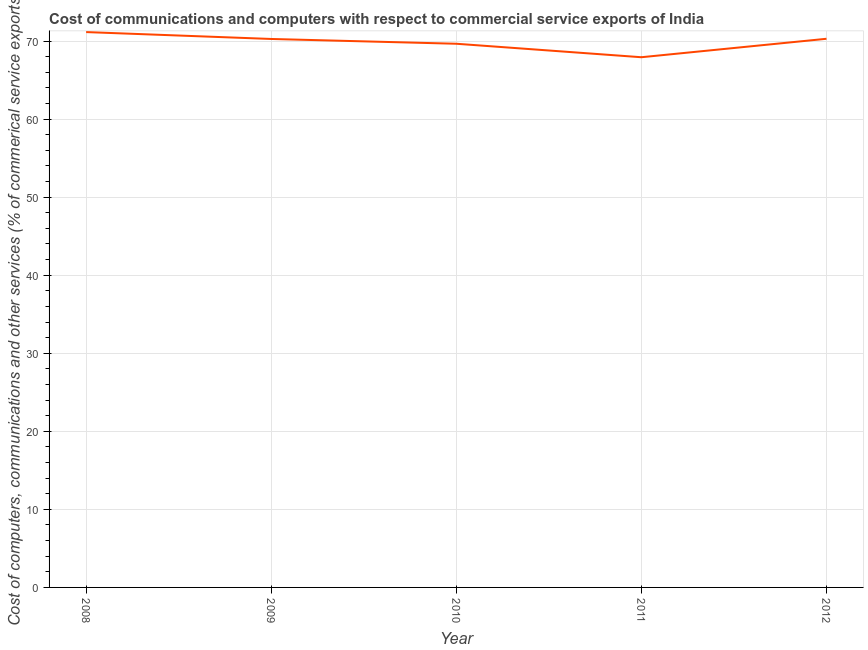What is the cost of communications in 2012?
Your response must be concise. 70.29. Across all years, what is the maximum  computer and other services?
Give a very brief answer. 71.15. Across all years, what is the minimum  computer and other services?
Provide a short and direct response. 67.93. What is the sum of the cost of communications?
Offer a very short reply. 349.28. What is the difference between the cost of communications in 2008 and 2009?
Provide a short and direct response. 0.88. What is the average cost of communications per year?
Make the answer very short. 69.86. What is the median cost of communications?
Your answer should be very brief. 70.27. In how many years, is the cost of communications greater than 52 %?
Your response must be concise. 5. What is the ratio of the cost of communications in 2009 to that in 2010?
Make the answer very short. 1.01. Is the cost of communications in 2008 less than that in 2010?
Make the answer very short. No. What is the difference between the highest and the second highest  computer and other services?
Offer a terse response. 0.86. What is the difference between the highest and the lowest  computer and other services?
Provide a succinct answer. 3.22. In how many years, is the  computer and other services greater than the average  computer and other services taken over all years?
Provide a succinct answer. 3. Does the  computer and other services monotonically increase over the years?
Provide a succinct answer. No. How many lines are there?
Give a very brief answer. 1. How many years are there in the graph?
Your answer should be compact. 5. What is the difference between two consecutive major ticks on the Y-axis?
Provide a succinct answer. 10. Are the values on the major ticks of Y-axis written in scientific E-notation?
Offer a terse response. No. Does the graph contain grids?
Provide a succinct answer. Yes. What is the title of the graph?
Keep it short and to the point. Cost of communications and computers with respect to commercial service exports of India. What is the label or title of the X-axis?
Provide a short and direct response. Year. What is the label or title of the Y-axis?
Keep it short and to the point. Cost of computers, communications and other services (% of commerical service exports). What is the Cost of computers, communications and other services (% of commerical service exports) of 2008?
Offer a very short reply. 71.15. What is the Cost of computers, communications and other services (% of commerical service exports) of 2009?
Keep it short and to the point. 70.27. What is the Cost of computers, communications and other services (% of commerical service exports) in 2010?
Your answer should be very brief. 69.65. What is the Cost of computers, communications and other services (% of commerical service exports) of 2011?
Offer a very short reply. 67.93. What is the Cost of computers, communications and other services (% of commerical service exports) in 2012?
Ensure brevity in your answer.  70.29. What is the difference between the Cost of computers, communications and other services (% of commerical service exports) in 2008 and 2009?
Keep it short and to the point. 0.88. What is the difference between the Cost of computers, communications and other services (% of commerical service exports) in 2008 and 2010?
Make the answer very short. 1.49. What is the difference between the Cost of computers, communications and other services (% of commerical service exports) in 2008 and 2011?
Your response must be concise. 3.22. What is the difference between the Cost of computers, communications and other services (% of commerical service exports) in 2008 and 2012?
Your answer should be compact. 0.86. What is the difference between the Cost of computers, communications and other services (% of commerical service exports) in 2009 and 2010?
Provide a succinct answer. 0.61. What is the difference between the Cost of computers, communications and other services (% of commerical service exports) in 2009 and 2011?
Ensure brevity in your answer.  2.34. What is the difference between the Cost of computers, communications and other services (% of commerical service exports) in 2009 and 2012?
Ensure brevity in your answer.  -0.03. What is the difference between the Cost of computers, communications and other services (% of commerical service exports) in 2010 and 2011?
Offer a terse response. 1.73. What is the difference between the Cost of computers, communications and other services (% of commerical service exports) in 2010 and 2012?
Offer a terse response. -0.64. What is the difference between the Cost of computers, communications and other services (% of commerical service exports) in 2011 and 2012?
Your answer should be very brief. -2.36. What is the ratio of the Cost of computers, communications and other services (% of commerical service exports) in 2008 to that in 2009?
Ensure brevity in your answer.  1.01. What is the ratio of the Cost of computers, communications and other services (% of commerical service exports) in 2008 to that in 2010?
Provide a succinct answer. 1.02. What is the ratio of the Cost of computers, communications and other services (% of commerical service exports) in 2008 to that in 2011?
Keep it short and to the point. 1.05. What is the ratio of the Cost of computers, communications and other services (% of commerical service exports) in 2008 to that in 2012?
Provide a short and direct response. 1.01. What is the ratio of the Cost of computers, communications and other services (% of commerical service exports) in 2009 to that in 2011?
Offer a terse response. 1.03. What is the ratio of the Cost of computers, communications and other services (% of commerical service exports) in 2011 to that in 2012?
Make the answer very short. 0.97. 